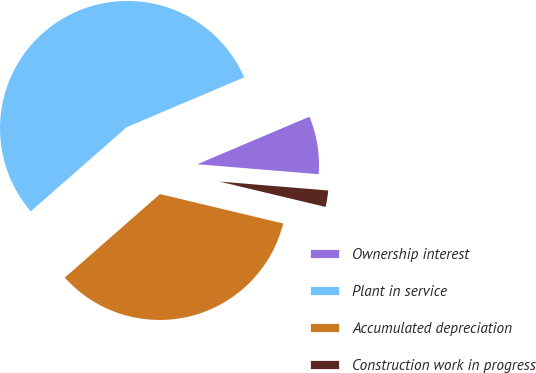<chart> <loc_0><loc_0><loc_500><loc_500><pie_chart><fcel>Ownership interest<fcel>Plant in service<fcel>Accumulated depreciation<fcel>Construction work in progress<nl><fcel>7.69%<fcel>55.08%<fcel>34.8%<fcel>2.43%<nl></chart> 